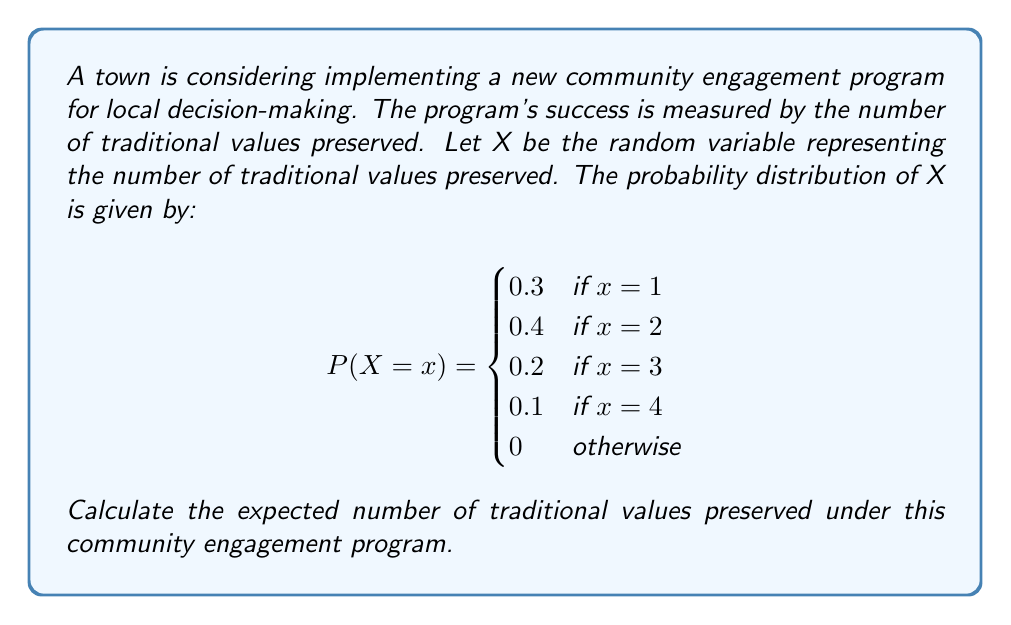Help me with this question. To calculate the expected value of a discrete random variable, we use the formula:

$$E(X) = \sum_{x} x \cdot P(X = x)$$

where $x$ represents each possible value of X, and $P(X = x)$ is the probability of X taking on that value.

Let's calculate step by step:

1) For $x = 1$: $1 \cdot P(X = 1) = 1 \cdot 0.3 = 0.3$
2) For $x = 2$: $2 \cdot P(X = 2) = 2 \cdot 0.4 = 0.8$
3) For $x = 3$: $3 \cdot P(X = 3) = 3 \cdot 0.2 = 0.6$
4) For $x = 4$: $4 \cdot P(X = 4) = 4 \cdot 0.1 = 0.4$

Now, we sum all these values:

$$E(X) = 0.3 + 0.8 + 0.6 + 0.4 = 2.1$$

Therefore, the expected number of traditional values preserved under this community engagement program is 2.1.
Answer: 2.1 